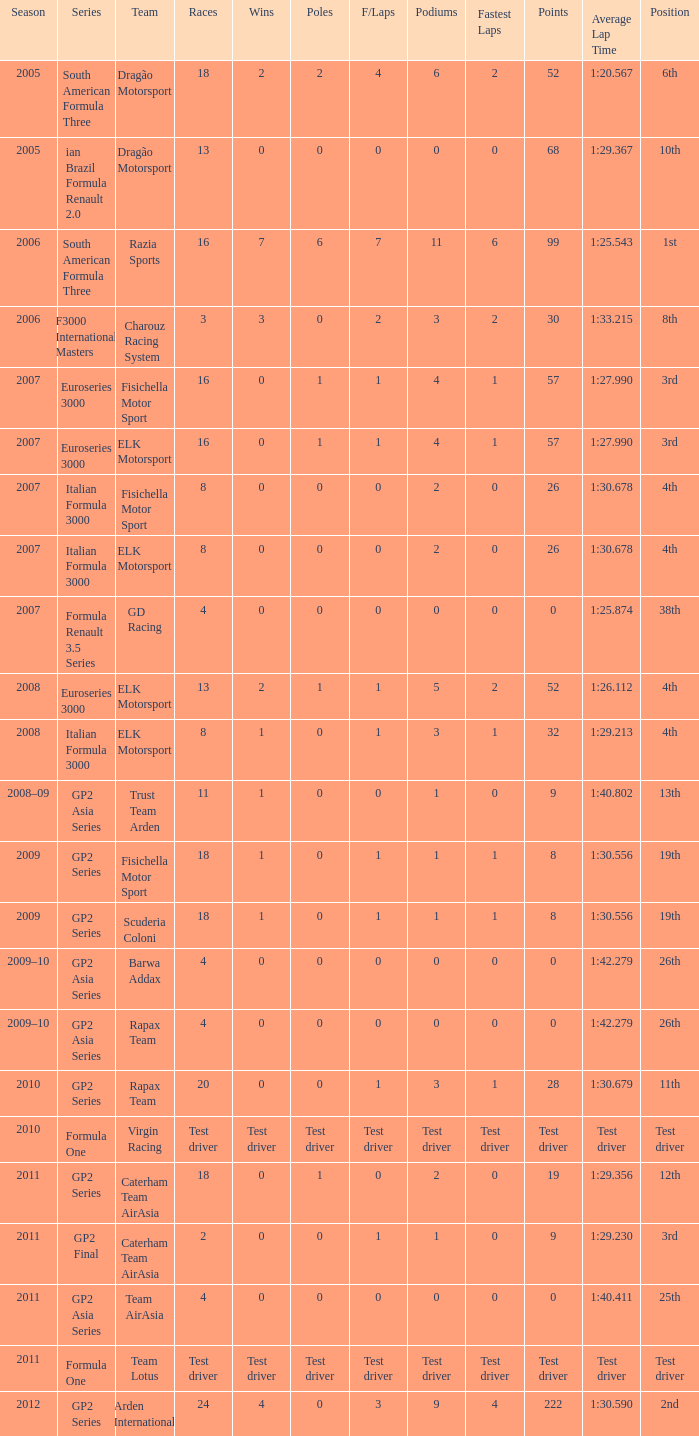Parse the table in full. {'header': ['Season', 'Series', 'Team', 'Races', 'Wins', 'Poles', 'F/Laps', 'Podiums', 'Fastest Laps', 'Points', 'Average Lap Time', 'Position'], 'rows': [['2005', 'South American Formula Three', 'Dragão Motorsport', '18', '2', '2', '4', '6', '2', '52', '1:20.567', '6th'], ['2005', 'ian Brazil Formula Renault 2.0', 'Dragão Motorsport', '13', '0', '0', '0', '0', '0', '68', '1:29.367', '10th'], ['2006', 'South American Formula Three', 'Razia Sports', '16', '7', '6', '7', '11', '6', '99', '1:25.543', '1st'], ['2006', 'F3000 International Masters', 'Charouz Racing System', '3', '3', '0', '2', '3', '2', '30', '1:33.215', '8th'], ['2007', 'Euroseries 3000', 'Fisichella Motor Sport', '16', '0', '1', '1', '4', '1', '57', '1:27.990', '3rd'], ['2007', 'Euroseries 3000', 'ELK Motorsport', '16', '0', '1', '1', '4', '1', '57', '1:27.990', '3rd'], ['2007', 'Italian Formula 3000', 'Fisichella Motor Sport', '8', '0', '0', '0', '2', '0', '26', '1:30.678', '4th'], ['2007', 'Italian Formula 3000', 'ELK Motorsport', '8', '0', '0', '0', '2', '0', '26', '1:30.678', '4th'], ['2007', 'Formula Renault 3.5 Series', 'GD Racing', '4', '0', '0', '0', '0', '0', '0', '1:25.874', '38th'], ['2008', 'Euroseries 3000', 'ELK Motorsport', '13', '2', '1', '1', '5', '2', '52', '1:26.112', '4th'], ['2008', 'Italian Formula 3000', 'ELK Motorsport', '8', '1', '0', '1', '3', '1', '32', '1:29.213', '4th'], ['2008–09', 'GP2 Asia Series', 'Trust Team Arden', '11', '1', '0', '0', '1', '0', '9', '1:40.802', '13th'], ['2009', 'GP2 Series', 'Fisichella Motor Sport', '18', '1', '0', '1', '1', '1', '8', '1:30.556', '19th'], ['2009', 'GP2 Series', 'Scuderia Coloni', '18', '1', '0', '1', '1', '1', '8', '1:30.556', '19th'], ['2009–10', 'GP2 Asia Series', 'Barwa Addax', '4', '0', '0', '0', '0', '0', '0', '1:42.279', '26th'], ['2009–10', 'GP2 Asia Series', 'Rapax Team', '4', '0', '0', '0', '0', '0', '0', '1:42.279', '26th'], ['2010', 'GP2 Series', 'Rapax Team', '20', '0', '0', '1', '3', '1', '28', '1:30.679', '11th'], ['2010', 'Formula One', 'Virgin Racing', 'Test driver', 'Test driver', 'Test driver', 'Test driver', 'Test driver', 'Test driver', 'Test driver', 'Test driver', 'Test driver'], ['2011', 'GP2 Series', 'Caterham Team AirAsia', '18', '0', '1', '0', '2', '0', '19', '1:29.356', '12th'], ['2011', 'GP2 Final', 'Caterham Team AirAsia', '2', '0', '0', '1', '1', '0', '9', '1:29.230', '3rd'], ['2011', 'GP2 Asia Series', 'Team AirAsia', '4', '0', '0', '0', '0', '0', '0', '1:40.411', '25th'], ['2011', 'Formula One', 'Team Lotus', 'Test driver', 'Test driver', 'Test driver', 'Test driver', 'Test driver', 'Test driver', 'Test driver', 'Test driver', 'Test driver'], ['2012', 'GP2 Series', 'Arden International', '24', '4', '0', '3', '9', '4', '222', '1:30.590', '2nd']]} What were the points in the year when his Podiums were 5? 52.0. 